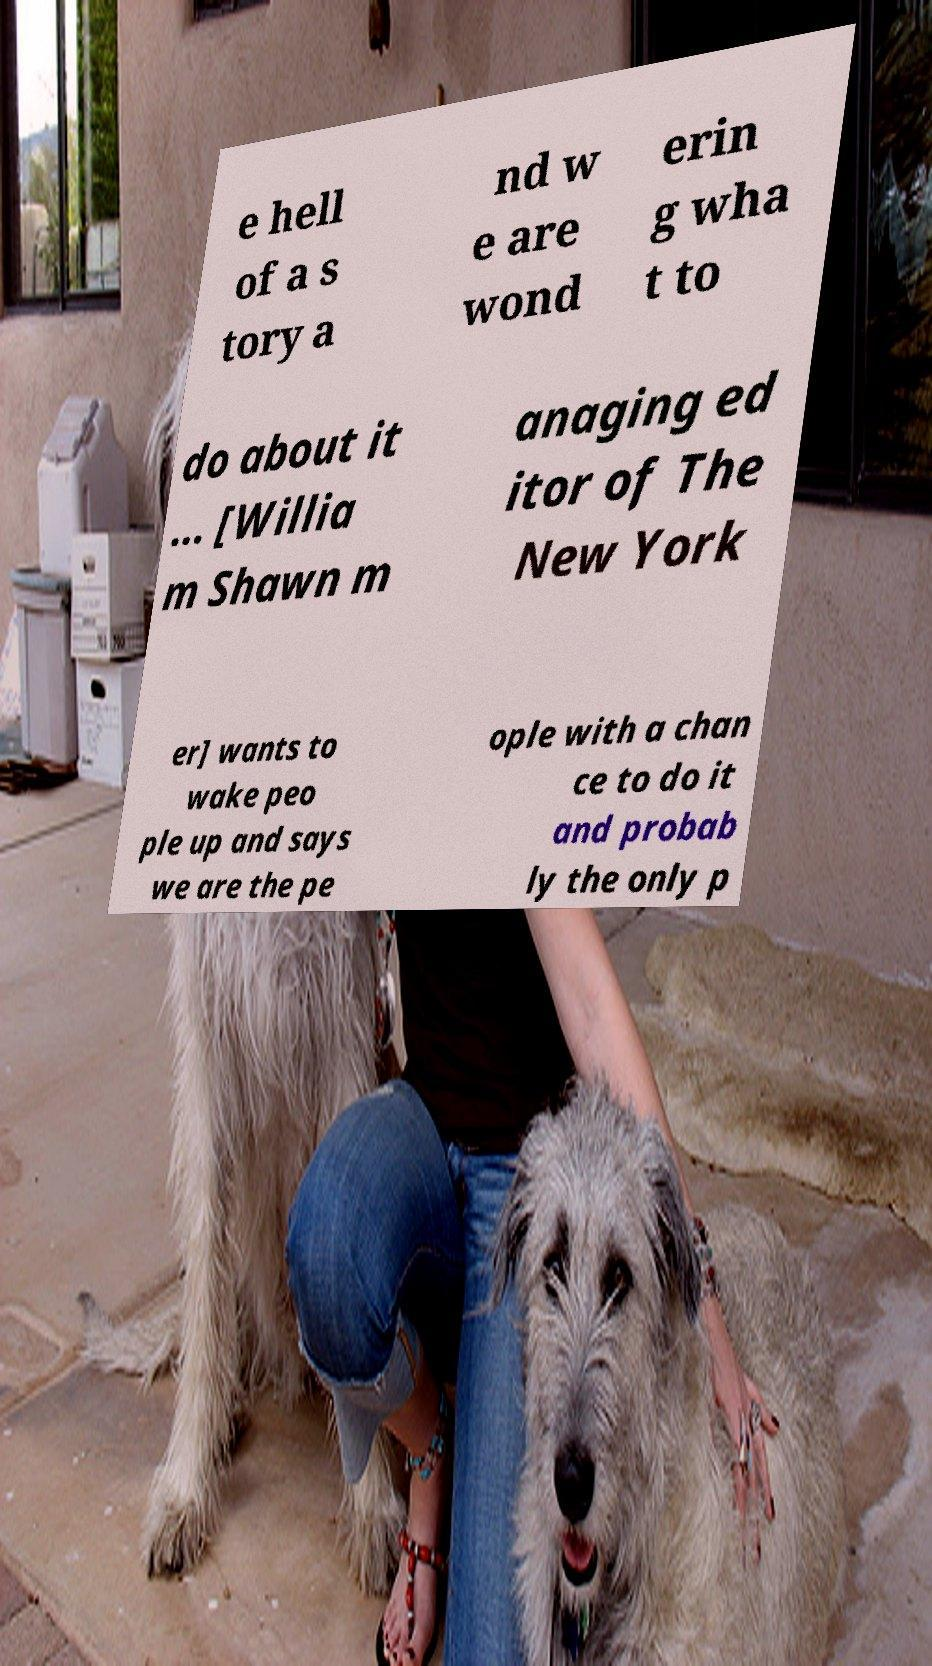Could you extract and type out the text from this image? e hell of a s tory a nd w e are wond erin g wha t to do about it ... [Willia m Shawn m anaging ed itor of The New York er] wants to wake peo ple up and says we are the pe ople with a chan ce to do it and probab ly the only p 